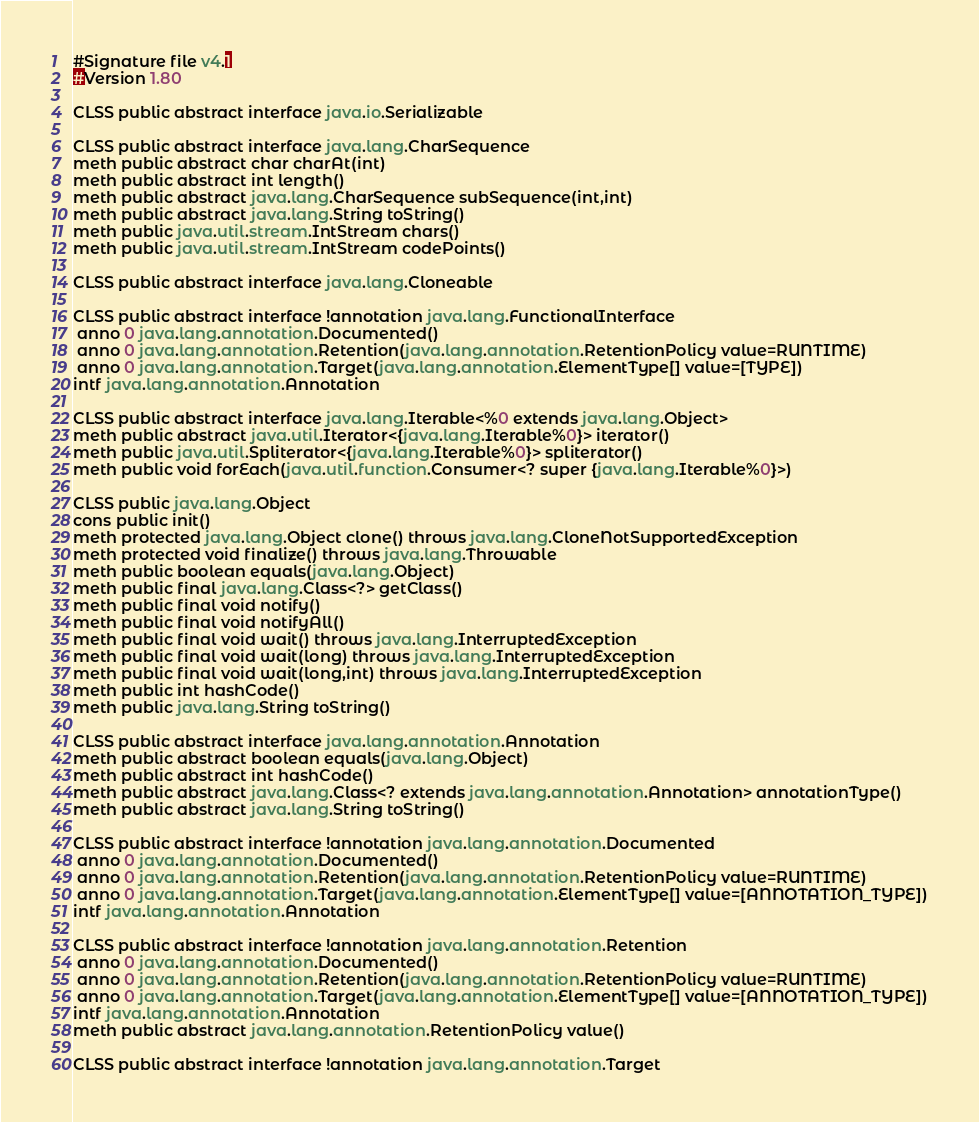Convert code to text. <code><loc_0><loc_0><loc_500><loc_500><_SML_>#Signature file v4.1
#Version 1.80

CLSS public abstract interface java.io.Serializable

CLSS public abstract interface java.lang.CharSequence
meth public abstract char charAt(int)
meth public abstract int length()
meth public abstract java.lang.CharSequence subSequence(int,int)
meth public abstract java.lang.String toString()
meth public java.util.stream.IntStream chars()
meth public java.util.stream.IntStream codePoints()

CLSS public abstract interface java.lang.Cloneable

CLSS public abstract interface !annotation java.lang.FunctionalInterface
 anno 0 java.lang.annotation.Documented()
 anno 0 java.lang.annotation.Retention(java.lang.annotation.RetentionPolicy value=RUNTIME)
 anno 0 java.lang.annotation.Target(java.lang.annotation.ElementType[] value=[TYPE])
intf java.lang.annotation.Annotation

CLSS public abstract interface java.lang.Iterable<%0 extends java.lang.Object>
meth public abstract java.util.Iterator<{java.lang.Iterable%0}> iterator()
meth public java.util.Spliterator<{java.lang.Iterable%0}> spliterator()
meth public void forEach(java.util.function.Consumer<? super {java.lang.Iterable%0}>)

CLSS public java.lang.Object
cons public init()
meth protected java.lang.Object clone() throws java.lang.CloneNotSupportedException
meth protected void finalize() throws java.lang.Throwable
meth public boolean equals(java.lang.Object)
meth public final java.lang.Class<?> getClass()
meth public final void notify()
meth public final void notifyAll()
meth public final void wait() throws java.lang.InterruptedException
meth public final void wait(long) throws java.lang.InterruptedException
meth public final void wait(long,int) throws java.lang.InterruptedException
meth public int hashCode()
meth public java.lang.String toString()

CLSS public abstract interface java.lang.annotation.Annotation
meth public abstract boolean equals(java.lang.Object)
meth public abstract int hashCode()
meth public abstract java.lang.Class<? extends java.lang.annotation.Annotation> annotationType()
meth public abstract java.lang.String toString()

CLSS public abstract interface !annotation java.lang.annotation.Documented
 anno 0 java.lang.annotation.Documented()
 anno 0 java.lang.annotation.Retention(java.lang.annotation.RetentionPolicy value=RUNTIME)
 anno 0 java.lang.annotation.Target(java.lang.annotation.ElementType[] value=[ANNOTATION_TYPE])
intf java.lang.annotation.Annotation

CLSS public abstract interface !annotation java.lang.annotation.Retention
 anno 0 java.lang.annotation.Documented()
 anno 0 java.lang.annotation.Retention(java.lang.annotation.RetentionPolicy value=RUNTIME)
 anno 0 java.lang.annotation.Target(java.lang.annotation.ElementType[] value=[ANNOTATION_TYPE])
intf java.lang.annotation.Annotation
meth public abstract java.lang.annotation.RetentionPolicy value()

CLSS public abstract interface !annotation java.lang.annotation.Target</code> 